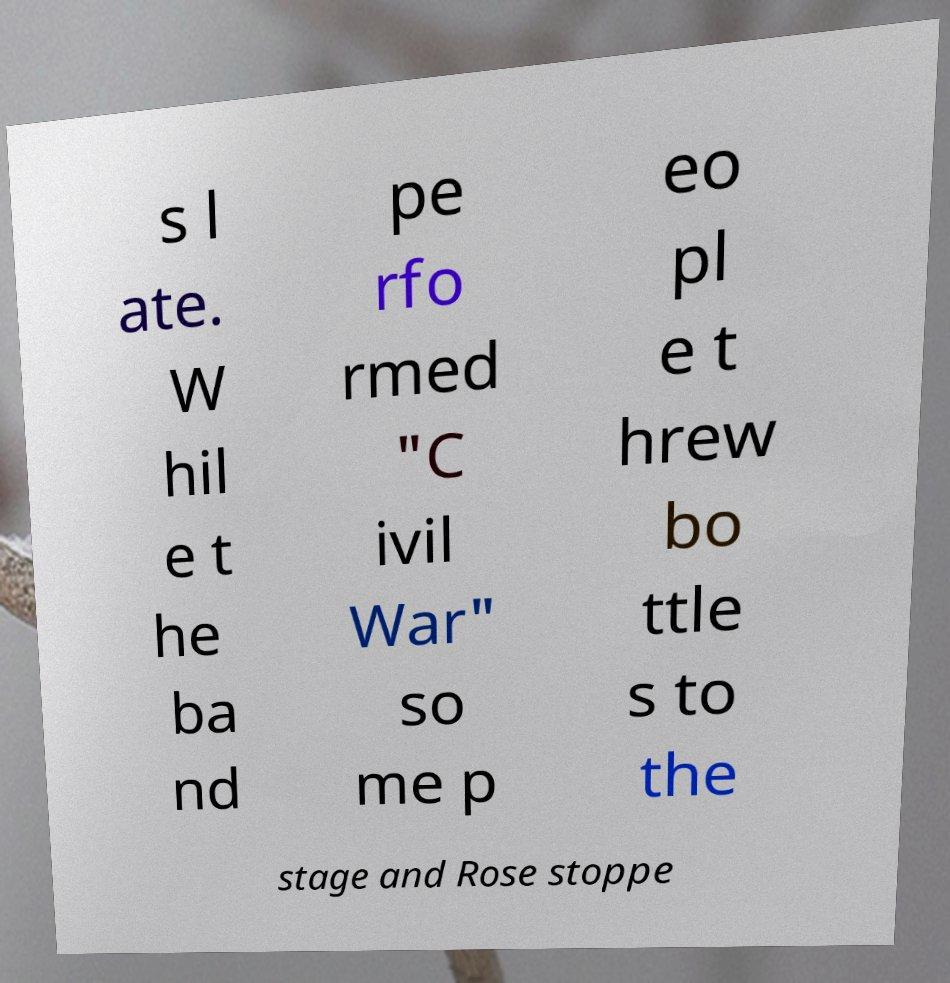What messages or text are displayed in this image? I need them in a readable, typed format. s l ate. W hil e t he ba nd pe rfo rmed "C ivil War" so me p eo pl e t hrew bo ttle s to the stage and Rose stoppe 